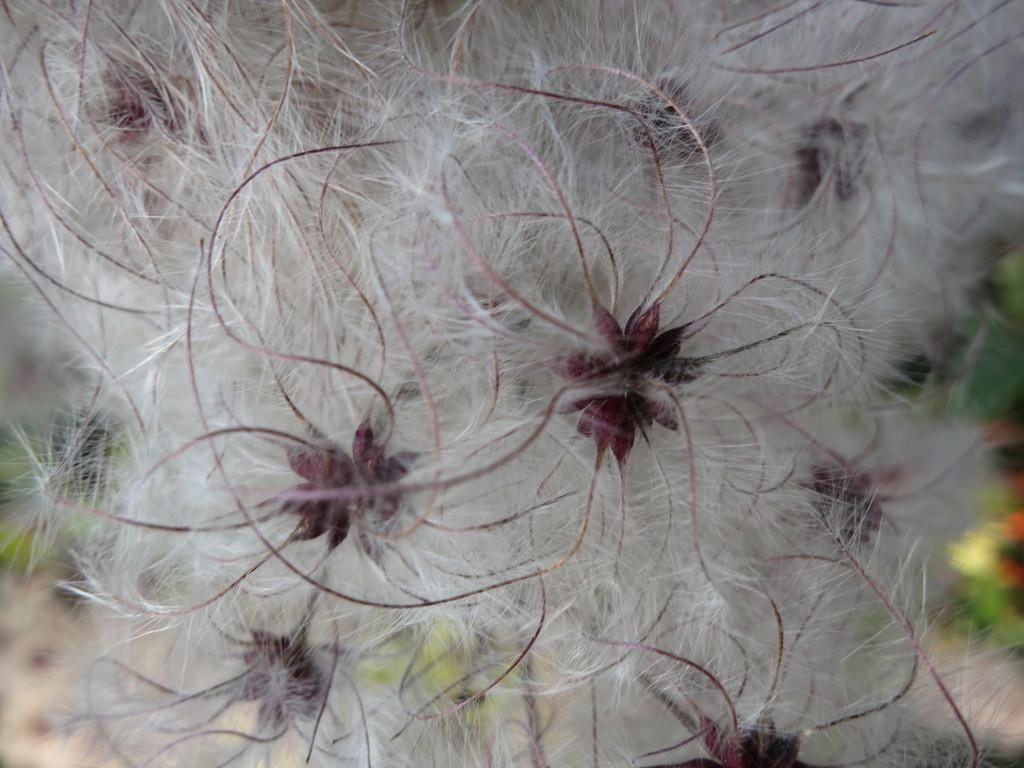What is the focus of the image? The image is zoomed in, and the focus is on a white color object in the center of the image. What is the white color object in the image? The white color object appears to be flowers. What can be seen in the background of the image? There are plants visible in the background of the image. What type of jewel is being played with in the image? There is no jewel or any indication of playing in the image; it features a zoomed-in view of flowers. How can the number of plants in the background be increased in the image? The number of plants in the background cannot be increased in the image; it is a static representation. 